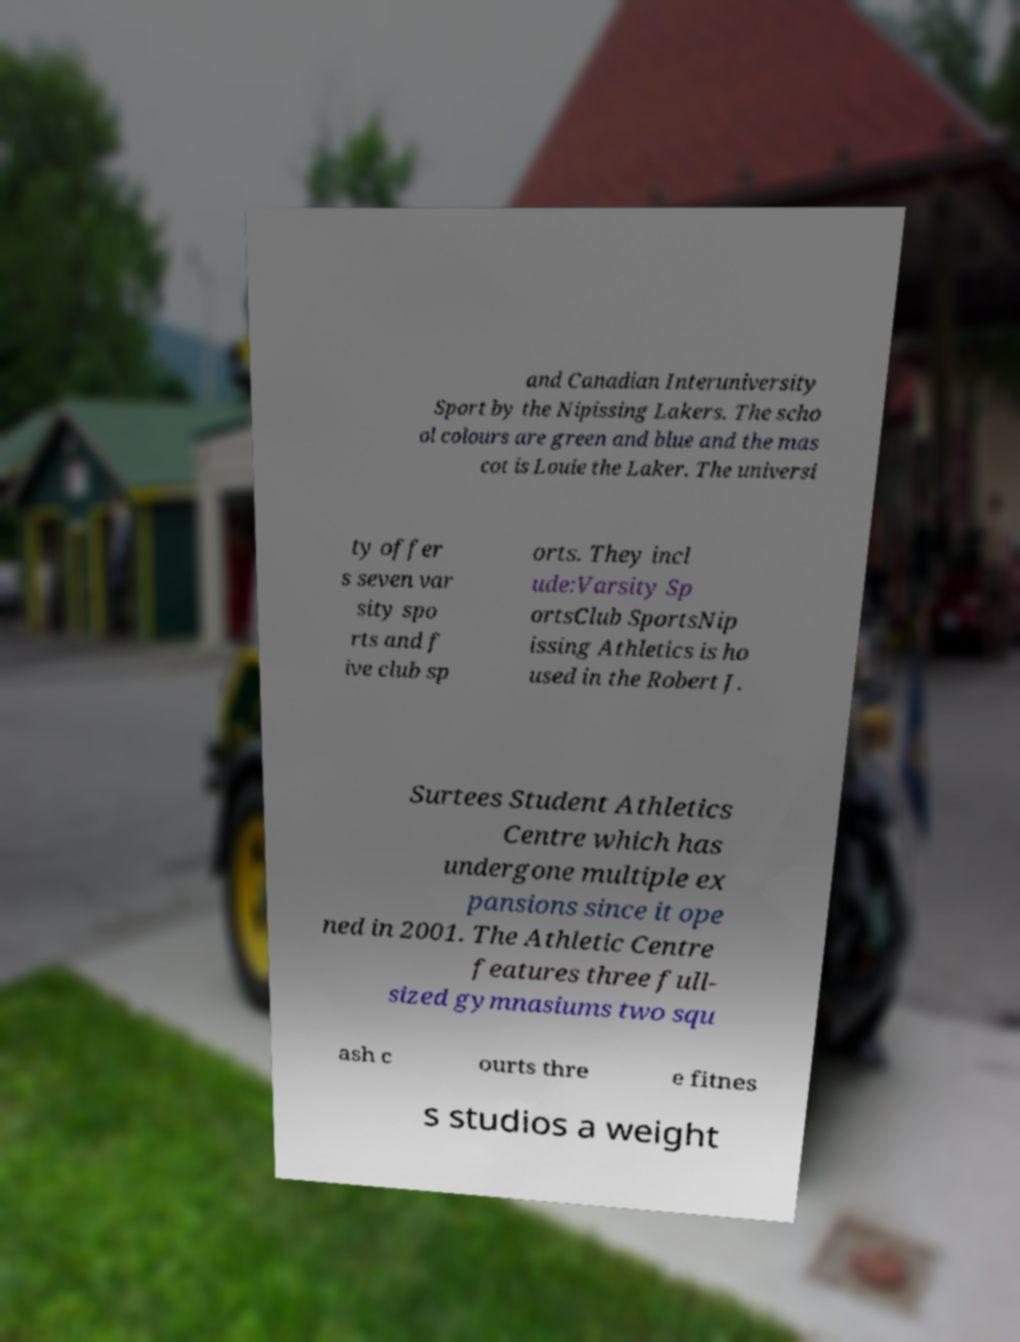For documentation purposes, I need the text within this image transcribed. Could you provide that? and Canadian Interuniversity Sport by the Nipissing Lakers. The scho ol colours are green and blue and the mas cot is Louie the Laker. The universi ty offer s seven var sity spo rts and f ive club sp orts. They incl ude:Varsity Sp ortsClub SportsNip issing Athletics is ho used in the Robert J. Surtees Student Athletics Centre which has undergone multiple ex pansions since it ope ned in 2001. The Athletic Centre features three full- sized gymnasiums two squ ash c ourts thre e fitnes s studios a weight 